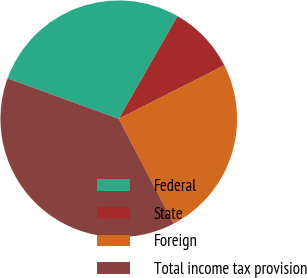Convert chart. <chart><loc_0><loc_0><loc_500><loc_500><pie_chart><fcel>Federal<fcel>State<fcel>Foreign<fcel>Total income tax provision<nl><fcel>27.72%<fcel>9.26%<fcel>24.79%<fcel>38.22%<nl></chart> 